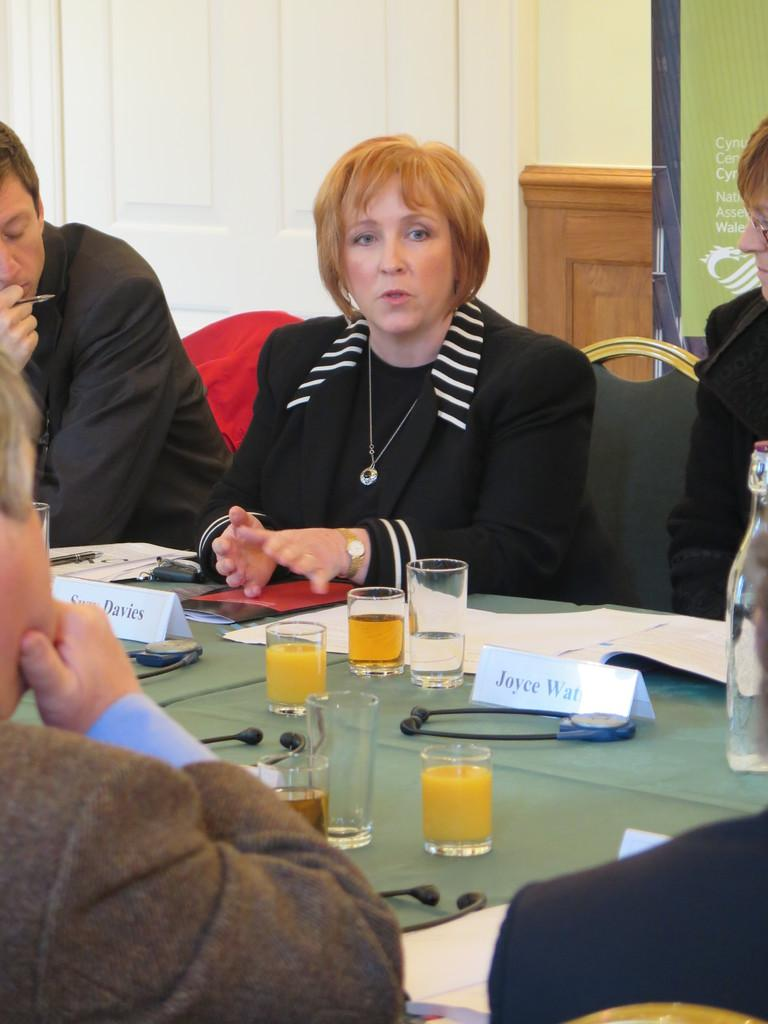What are the people in the image doing? The people in the image are sitting on chairs. What objects are in front of the people? There are juice glasses in front of the people. What type of grain is being harvested in the image? There is no grain or harvesting activity present in the image. What kind of jewel is being displayed on the table in the image? There is no jewel present in the image; it features people sitting on chairs with juice glasses in front of them. 